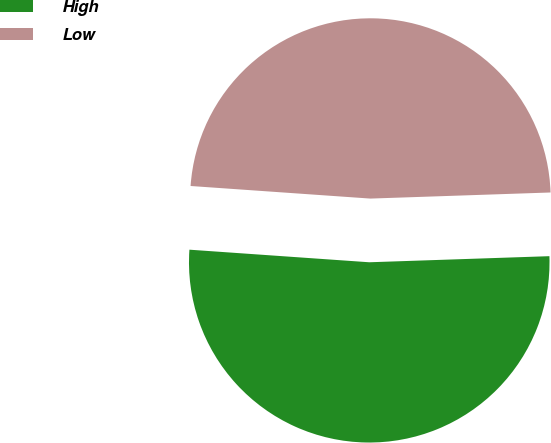Convert chart. <chart><loc_0><loc_0><loc_500><loc_500><pie_chart><fcel>High<fcel>Low<nl><fcel>51.65%<fcel>48.35%<nl></chart> 